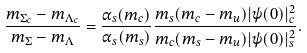Convert formula to latex. <formula><loc_0><loc_0><loc_500><loc_500>\frac { m _ { \Sigma _ { c } } - m _ { \Lambda _ { c } } } { m _ { \Sigma } - m _ { \Lambda } } = \frac { \alpha _ { s } ( m _ { c } ) } { \alpha _ { s } ( m _ { s } ) } \frac { m _ { s } ( m _ { c } - m _ { u } ) | \psi ( 0 ) | _ { c } ^ { 2 } } { m _ { c } ( m _ { s } - m _ { u } ) | \psi ( 0 ) | _ { s } ^ { 2 } } .</formula> 